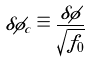Convert formula to latex. <formula><loc_0><loc_0><loc_500><loc_500>\delta \phi _ { c } \equiv \frac { \delta \phi } { \sqrt { f _ { 0 } } }</formula> 